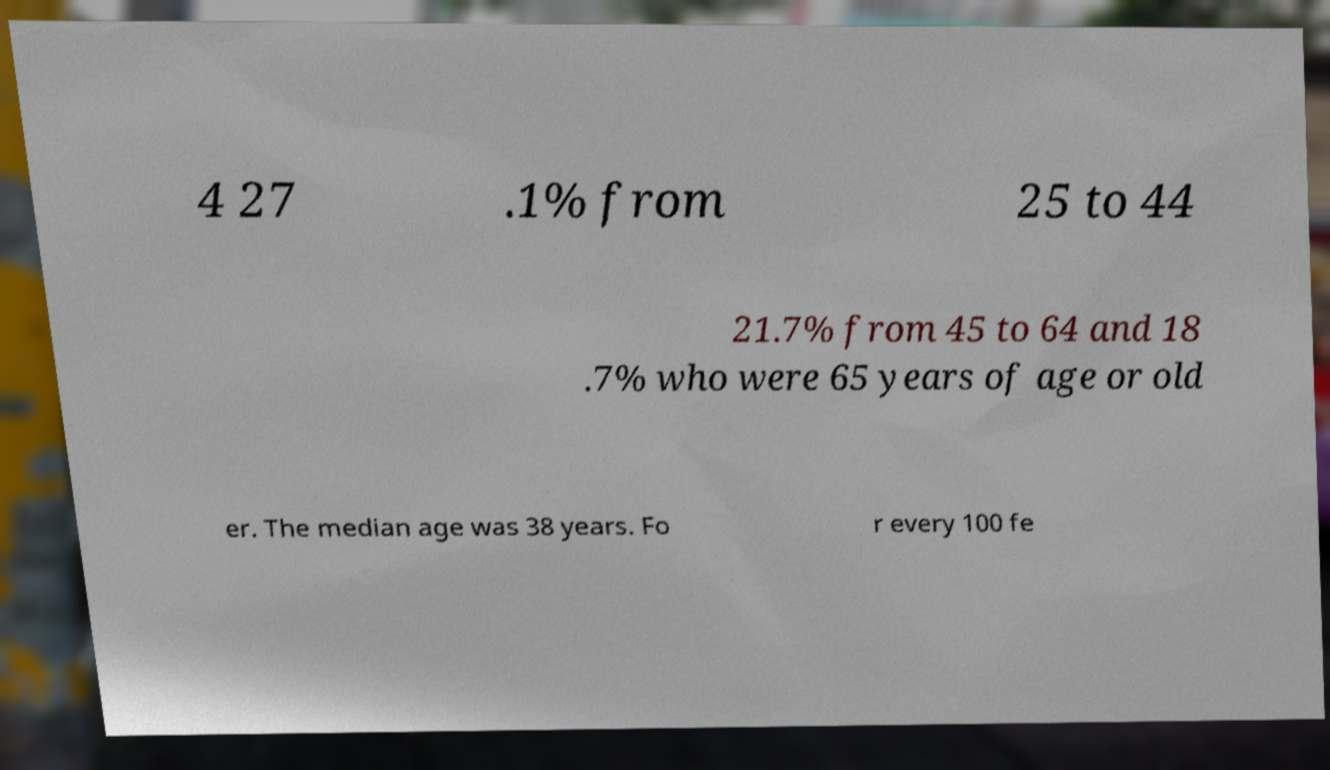What messages or text are displayed in this image? I need them in a readable, typed format. 4 27 .1% from 25 to 44 21.7% from 45 to 64 and 18 .7% who were 65 years of age or old er. The median age was 38 years. Fo r every 100 fe 